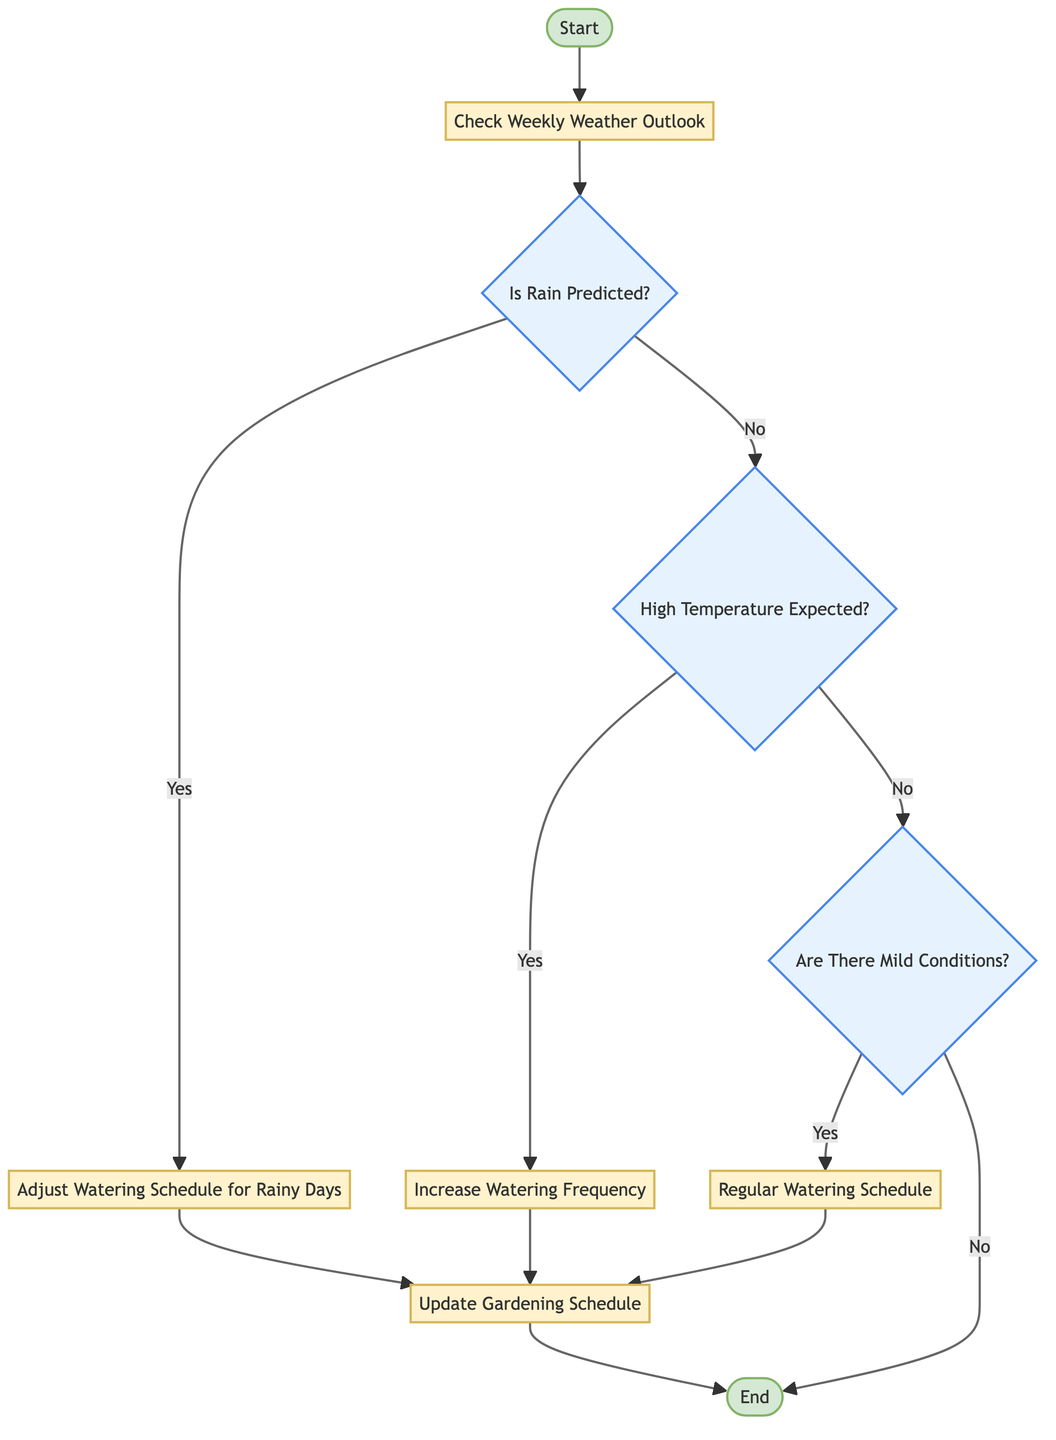What is the first action in the flow chart? The first action in the flow chart is labeled as "Start," which initiates the process. It is the first node connected in the diagram.
Answer: Start How many decision nodes are present? There are three decision nodes in the flow chart: "Is Rain Predicted?", "High Temperature Expected?", and "Are There Mild Conditions?". Each decision leads to different paths based on the answers.
Answer: Three What follows after "Adjust Watering Schedule for Rainy Days"? After "Adjust Watering Schedule for Rainy Days," the next action is "Update Gardening Schedule," which records the adjustments made to the watering schedule.
Answer: Update Gardening Schedule If "High Temperature Expected?" is answered "No," what is the next decision? If "High Temperature Expected?" is answered "No," the next decision is "Are There Mild Conditions?". This continues the evaluation of the weather conditions in relation to watering.
Answer: Are There Mild Conditions? What is the final action before the flow chart ends? The final action before the flow chart ends is "Update Gardening Schedule." This action records the decisions made throughout the process before concluding.
Answer: Update Gardening Schedule If rain is predicted, what action is taken? If rain is predicted, the action taken is to "Adjust Watering Schedule for Rainy Days," which means reducing or skipping watering on those days.
Answer: Adjust Watering Schedule for Rainy Days What happens if "Are There Mild Conditions?" is answered "No"? If "Are There Mild Conditions?" is answered "No," the flow chart leads directly to the "End" node, indicating no further adjustments are needed.
Answer: End What type of nodes make up the flow chart? The flow chart consists of "StartEvent," "Task," and "Decision" nodes, which serve different purposes in depicting the procedural flow of the watering schedule adjustments.
Answer: StartEvent, Task, Decision 